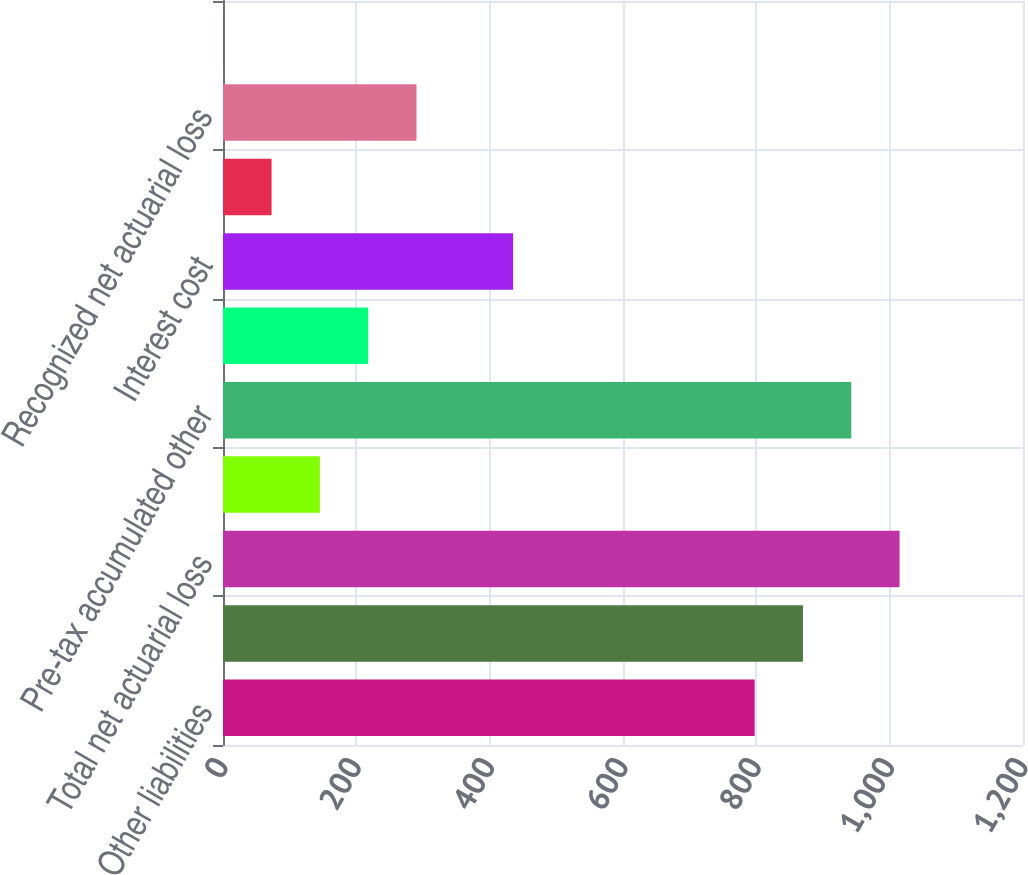Convert chart. <chart><loc_0><loc_0><loc_500><loc_500><bar_chart><fcel>Other liabilities<fcel>Total<fcel>Total net actuarial loss<fcel>Prior service benefit<fcel>Pre-tax accumulated other<fcel>Service cost<fcel>Interest cost<fcel>Amortization of prior service<fcel>Recognized net actuarial loss<fcel>Amounts recognized due to<nl><fcel>797.46<fcel>869.92<fcel>1014.84<fcel>145.32<fcel>942.38<fcel>217.78<fcel>435.16<fcel>72.86<fcel>290.24<fcel>0.4<nl></chart> 